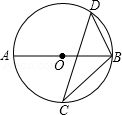First perform reasoning, then finally select the question from the choices in the following format: Answer: xxx.
Question: Consider the given diagram, where AB represents the diameter of circle O and C and D are two points on circle O. Let's denote the degree measure of angle BCD as variable 'h' (h = 40.0 degrees). What is the degree measure of angle ABD, expressed as variable 'k' in relation to 'h'?
Choices:
A: 20°
B: 40°
C: 50°
D: 60° To find the degree measure of angle ABD, we apply the fact that angle ADB is a right angle (90 degrees) due to AB being the diameter of circle O. Furthermore, we are provided with the degree measure of angle BCD as h degrees. Consequently, the degree measure of angle A is also h degrees. By utilizing the angle sum property of a triangle (180 degrees), we can deduce that the degree measure of angle ABD is equal to 180 degrees minus the degree measure of angle ADB minus the degree measure of angle BCD. Substituting the given values, we have k = 180 degrees - 90 degrees - h degrees. Simplifying this equation, we obtain k = 90 degrees - h degrees. Therefore, the degree measure of angle ABD is 90 degrees minus h degrees. Thus, the answer is option C.
Answer:C 